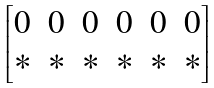<formula> <loc_0><loc_0><loc_500><loc_500>\begin{bmatrix} 0 & 0 & 0 & 0 & 0 & 0 \\ * & * & * & * & * & * \\ \end{bmatrix}</formula> 